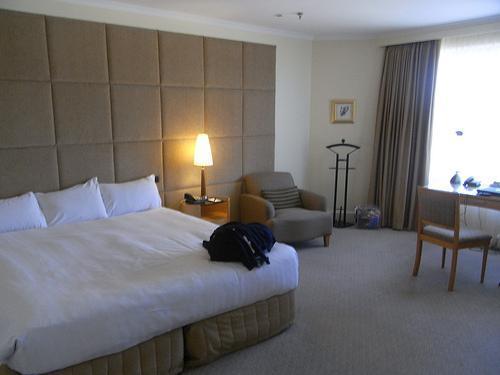How many beds are in the photo?
Give a very brief answer. 1. How many lamps are in the room?
Give a very brief answer. 1. 